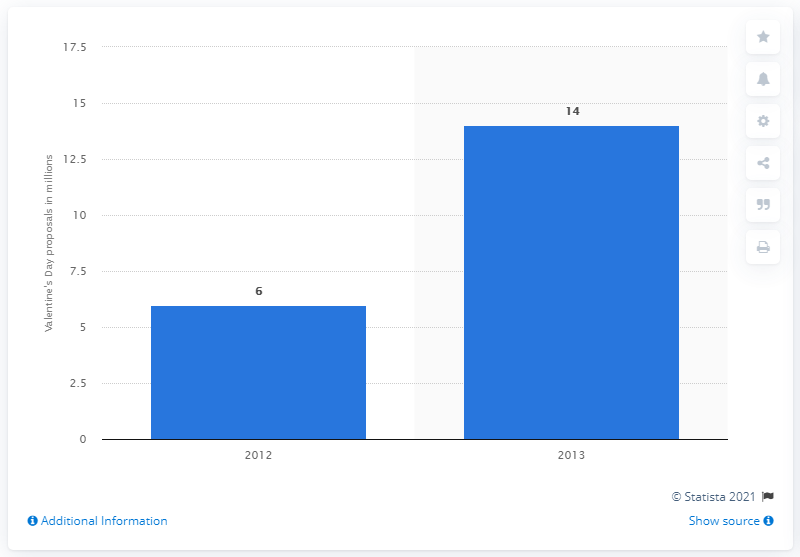Highlight a few significant elements in this photo. On Valentine's Day in 2012, 14 couples were expecting engagement. In 2013, 14 couples were expecting an engagement on Valentine's Day. 